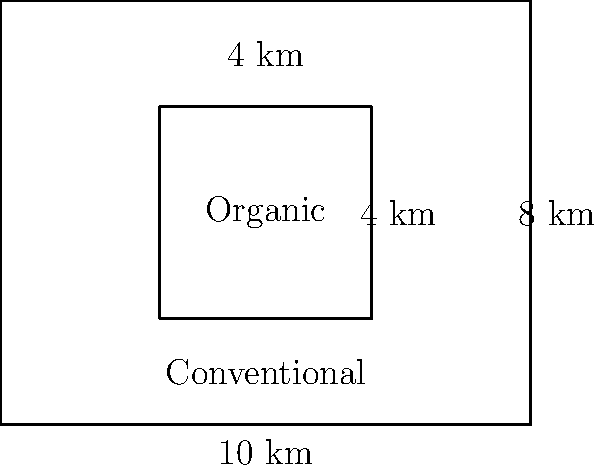In a legislative district, there are plans to compare conventional and organic farming zones. The entire district is rectangular, measuring 10 km by 8 km. An organic farming zone is proposed within the district, represented by the inner rectangle. If the organic zone measures 4 km by 4 km, what percentage of the district's total area would be dedicated to organic farming? To solve this problem, we need to follow these steps:

1. Calculate the total area of the legislative district:
   $A_{total} = 10 \text{ km} \times 8 \text{ km} = 80 \text{ km}^2$

2. Calculate the area of the organic farming zone:
   $A_{organic} = 4 \text{ km} \times 4 \text{ km} = 16 \text{ km}^2$

3. Calculate the percentage of the district dedicated to organic farming:
   $\text{Percentage} = \frac{A_{organic}}{A_{total}} \times 100\%$
   
   $\text{Percentage} = \frac{16 \text{ km}^2}{80 \text{ km}^2} \times 100\%$
   
   $\text{Percentage} = 0.2 \times 100\% = 20\%$

Therefore, 20% of the district's total area would be dedicated to organic farming.
Answer: 20% 